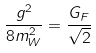<formula> <loc_0><loc_0><loc_500><loc_500>\frac { g ^ { 2 } } { 8 m _ { W } ^ { 2 } } = \frac { G _ { F } } { \sqrt { 2 } }</formula> 